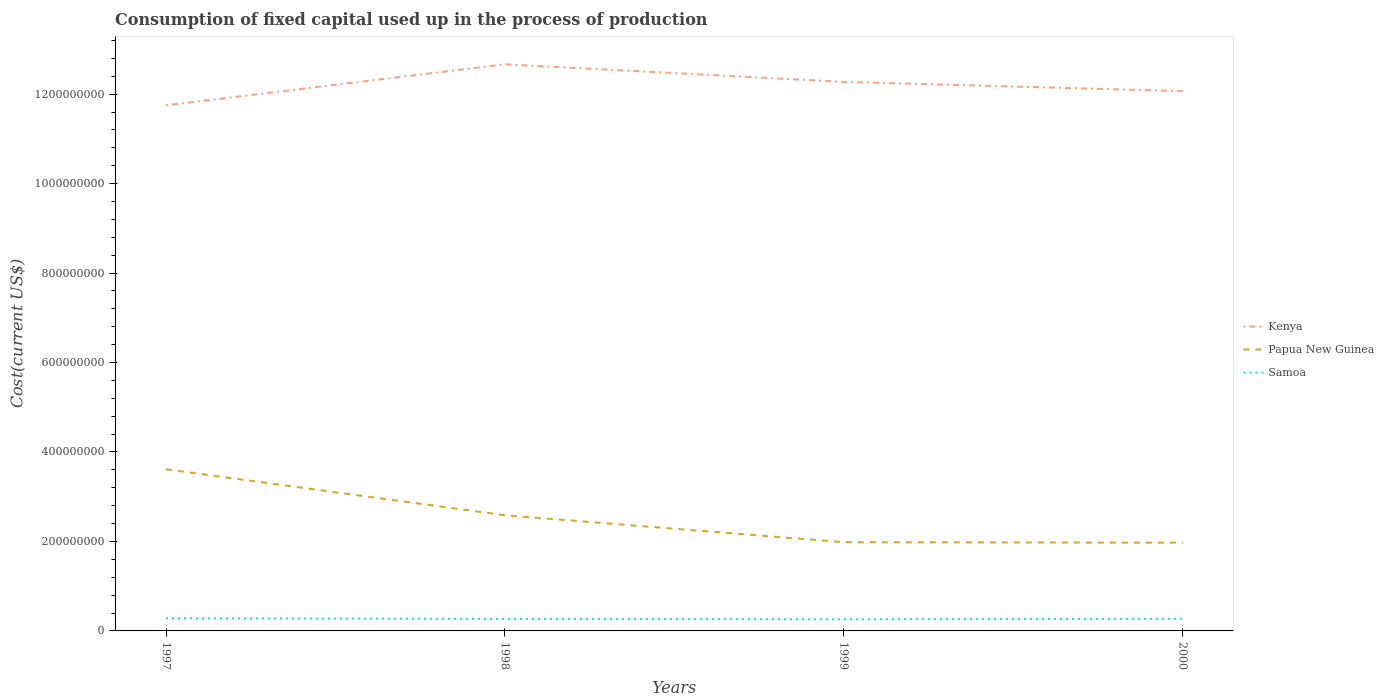How many different coloured lines are there?
Make the answer very short. 3. Is the number of lines equal to the number of legend labels?
Offer a very short reply. Yes. Across all years, what is the maximum amount consumed in the process of production in Papua New Guinea?
Keep it short and to the point. 1.97e+08. What is the total amount consumed in the process of production in Kenya in the graph?
Offer a terse response. -5.23e+07. What is the difference between the highest and the second highest amount consumed in the process of production in Kenya?
Offer a very short reply. 9.15e+07. Is the amount consumed in the process of production in Papua New Guinea strictly greater than the amount consumed in the process of production in Samoa over the years?
Keep it short and to the point. No. How many years are there in the graph?
Ensure brevity in your answer.  4. What is the difference between two consecutive major ticks on the Y-axis?
Make the answer very short. 2.00e+08. Does the graph contain grids?
Provide a succinct answer. No. How many legend labels are there?
Keep it short and to the point. 3. How are the legend labels stacked?
Make the answer very short. Vertical. What is the title of the graph?
Provide a succinct answer. Consumption of fixed capital used up in the process of production. Does "Least developed countries" appear as one of the legend labels in the graph?
Your answer should be compact. No. What is the label or title of the Y-axis?
Provide a succinct answer. Cost(current US$). What is the Cost(current US$) in Kenya in 1997?
Keep it short and to the point. 1.18e+09. What is the Cost(current US$) of Papua New Guinea in 1997?
Make the answer very short. 3.61e+08. What is the Cost(current US$) in Samoa in 1997?
Make the answer very short. 2.85e+07. What is the Cost(current US$) in Kenya in 1998?
Your answer should be very brief. 1.27e+09. What is the Cost(current US$) in Papua New Guinea in 1998?
Offer a very short reply. 2.59e+08. What is the Cost(current US$) of Samoa in 1998?
Ensure brevity in your answer.  2.67e+07. What is the Cost(current US$) of Kenya in 1999?
Your answer should be very brief. 1.23e+09. What is the Cost(current US$) of Papua New Guinea in 1999?
Your response must be concise. 1.98e+08. What is the Cost(current US$) in Samoa in 1999?
Your answer should be very brief. 2.60e+07. What is the Cost(current US$) of Kenya in 2000?
Keep it short and to the point. 1.21e+09. What is the Cost(current US$) of Papua New Guinea in 2000?
Make the answer very short. 1.97e+08. What is the Cost(current US$) in Samoa in 2000?
Give a very brief answer. 2.71e+07. Across all years, what is the maximum Cost(current US$) of Kenya?
Offer a very short reply. 1.27e+09. Across all years, what is the maximum Cost(current US$) of Papua New Guinea?
Your answer should be compact. 3.61e+08. Across all years, what is the maximum Cost(current US$) of Samoa?
Provide a short and direct response. 2.85e+07. Across all years, what is the minimum Cost(current US$) of Kenya?
Provide a short and direct response. 1.18e+09. Across all years, what is the minimum Cost(current US$) of Papua New Guinea?
Your answer should be compact. 1.97e+08. Across all years, what is the minimum Cost(current US$) of Samoa?
Provide a succinct answer. 2.60e+07. What is the total Cost(current US$) in Kenya in the graph?
Keep it short and to the point. 4.88e+09. What is the total Cost(current US$) of Papua New Guinea in the graph?
Provide a succinct answer. 1.02e+09. What is the total Cost(current US$) of Samoa in the graph?
Provide a short and direct response. 1.08e+08. What is the difference between the Cost(current US$) of Kenya in 1997 and that in 1998?
Your response must be concise. -9.15e+07. What is the difference between the Cost(current US$) of Papua New Guinea in 1997 and that in 1998?
Offer a very short reply. 1.03e+08. What is the difference between the Cost(current US$) in Samoa in 1997 and that in 1998?
Offer a very short reply. 1.81e+06. What is the difference between the Cost(current US$) in Kenya in 1997 and that in 1999?
Offer a terse response. -5.23e+07. What is the difference between the Cost(current US$) of Papua New Guinea in 1997 and that in 1999?
Your answer should be very brief. 1.63e+08. What is the difference between the Cost(current US$) of Samoa in 1997 and that in 1999?
Ensure brevity in your answer.  2.57e+06. What is the difference between the Cost(current US$) of Kenya in 1997 and that in 2000?
Ensure brevity in your answer.  -3.15e+07. What is the difference between the Cost(current US$) in Papua New Guinea in 1997 and that in 2000?
Provide a succinct answer. 1.64e+08. What is the difference between the Cost(current US$) in Samoa in 1997 and that in 2000?
Provide a succinct answer. 1.40e+06. What is the difference between the Cost(current US$) in Kenya in 1998 and that in 1999?
Make the answer very short. 3.92e+07. What is the difference between the Cost(current US$) of Papua New Guinea in 1998 and that in 1999?
Give a very brief answer. 6.02e+07. What is the difference between the Cost(current US$) in Samoa in 1998 and that in 1999?
Provide a succinct answer. 7.52e+05. What is the difference between the Cost(current US$) of Kenya in 1998 and that in 2000?
Give a very brief answer. 6.00e+07. What is the difference between the Cost(current US$) of Papua New Guinea in 1998 and that in 2000?
Offer a very short reply. 6.14e+07. What is the difference between the Cost(current US$) in Samoa in 1998 and that in 2000?
Provide a succinct answer. -4.18e+05. What is the difference between the Cost(current US$) of Kenya in 1999 and that in 2000?
Give a very brief answer. 2.08e+07. What is the difference between the Cost(current US$) in Papua New Guinea in 1999 and that in 2000?
Make the answer very short. 1.19e+06. What is the difference between the Cost(current US$) of Samoa in 1999 and that in 2000?
Your answer should be very brief. -1.17e+06. What is the difference between the Cost(current US$) of Kenya in 1997 and the Cost(current US$) of Papua New Guinea in 1998?
Offer a terse response. 9.17e+08. What is the difference between the Cost(current US$) in Kenya in 1997 and the Cost(current US$) in Samoa in 1998?
Offer a terse response. 1.15e+09. What is the difference between the Cost(current US$) of Papua New Guinea in 1997 and the Cost(current US$) of Samoa in 1998?
Your answer should be very brief. 3.35e+08. What is the difference between the Cost(current US$) of Kenya in 1997 and the Cost(current US$) of Papua New Guinea in 1999?
Your answer should be very brief. 9.77e+08. What is the difference between the Cost(current US$) in Kenya in 1997 and the Cost(current US$) in Samoa in 1999?
Offer a very short reply. 1.15e+09. What is the difference between the Cost(current US$) in Papua New Guinea in 1997 and the Cost(current US$) in Samoa in 1999?
Ensure brevity in your answer.  3.35e+08. What is the difference between the Cost(current US$) of Kenya in 1997 and the Cost(current US$) of Papua New Guinea in 2000?
Your answer should be compact. 9.78e+08. What is the difference between the Cost(current US$) in Kenya in 1997 and the Cost(current US$) in Samoa in 2000?
Make the answer very short. 1.15e+09. What is the difference between the Cost(current US$) in Papua New Guinea in 1997 and the Cost(current US$) in Samoa in 2000?
Offer a terse response. 3.34e+08. What is the difference between the Cost(current US$) of Kenya in 1998 and the Cost(current US$) of Papua New Guinea in 1999?
Provide a short and direct response. 1.07e+09. What is the difference between the Cost(current US$) of Kenya in 1998 and the Cost(current US$) of Samoa in 1999?
Your answer should be compact. 1.24e+09. What is the difference between the Cost(current US$) in Papua New Guinea in 1998 and the Cost(current US$) in Samoa in 1999?
Offer a very short reply. 2.33e+08. What is the difference between the Cost(current US$) in Kenya in 1998 and the Cost(current US$) in Papua New Guinea in 2000?
Offer a very short reply. 1.07e+09. What is the difference between the Cost(current US$) of Kenya in 1998 and the Cost(current US$) of Samoa in 2000?
Provide a succinct answer. 1.24e+09. What is the difference between the Cost(current US$) in Papua New Guinea in 1998 and the Cost(current US$) in Samoa in 2000?
Provide a succinct answer. 2.31e+08. What is the difference between the Cost(current US$) of Kenya in 1999 and the Cost(current US$) of Papua New Guinea in 2000?
Offer a terse response. 1.03e+09. What is the difference between the Cost(current US$) in Kenya in 1999 and the Cost(current US$) in Samoa in 2000?
Offer a terse response. 1.20e+09. What is the difference between the Cost(current US$) in Papua New Guinea in 1999 and the Cost(current US$) in Samoa in 2000?
Provide a succinct answer. 1.71e+08. What is the average Cost(current US$) of Kenya per year?
Make the answer very short. 1.22e+09. What is the average Cost(current US$) of Papua New Guinea per year?
Your answer should be compact. 2.54e+08. What is the average Cost(current US$) of Samoa per year?
Your response must be concise. 2.71e+07. In the year 1997, what is the difference between the Cost(current US$) in Kenya and Cost(current US$) in Papua New Guinea?
Offer a terse response. 8.14e+08. In the year 1997, what is the difference between the Cost(current US$) in Kenya and Cost(current US$) in Samoa?
Keep it short and to the point. 1.15e+09. In the year 1997, what is the difference between the Cost(current US$) of Papua New Guinea and Cost(current US$) of Samoa?
Offer a very short reply. 3.33e+08. In the year 1998, what is the difference between the Cost(current US$) of Kenya and Cost(current US$) of Papua New Guinea?
Your answer should be very brief. 1.01e+09. In the year 1998, what is the difference between the Cost(current US$) in Kenya and Cost(current US$) in Samoa?
Ensure brevity in your answer.  1.24e+09. In the year 1998, what is the difference between the Cost(current US$) in Papua New Guinea and Cost(current US$) in Samoa?
Your response must be concise. 2.32e+08. In the year 1999, what is the difference between the Cost(current US$) of Kenya and Cost(current US$) of Papua New Guinea?
Keep it short and to the point. 1.03e+09. In the year 1999, what is the difference between the Cost(current US$) in Kenya and Cost(current US$) in Samoa?
Ensure brevity in your answer.  1.20e+09. In the year 1999, what is the difference between the Cost(current US$) in Papua New Guinea and Cost(current US$) in Samoa?
Provide a succinct answer. 1.72e+08. In the year 2000, what is the difference between the Cost(current US$) in Kenya and Cost(current US$) in Papua New Guinea?
Your response must be concise. 1.01e+09. In the year 2000, what is the difference between the Cost(current US$) of Kenya and Cost(current US$) of Samoa?
Your response must be concise. 1.18e+09. In the year 2000, what is the difference between the Cost(current US$) in Papua New Guinea and Cost(current US$) in Samoa?
Your response must be concise. 1.70e+08. What is the ratio of the Cost(current US$) of Kenya in 1997 to that in 1998?
Make the answer very short. 0.93. What is the ratio of the Cost(current US$) in Papua New Guinea in 1997 to that in 1998?
Offer a very short reply. 1.4. What is the ratio of the Cost(current US$) of Samoa in 1997 to that in 1998?
Provide a short and direct response. 1.07. What is the ratio of the Cost(current US$) in Kenya in 1997 to that in 1999?
Offer a terse response. 0.96. What is the ratio of the Cost(current US$) of Papua New Guinea in 1997 to that in 1999?
Give a very brief answer. 1.82. What is the ratio of the Cost(current US$) in Samoa in 1997 to that in 1999?
Your answer should be compact. 1.1. What is the ratio of the Cost(current US$) in Kenya in 1997 to that in 2000?
Keep it short and to the point. 0.97. What is the ratio of the Cost(current US$) in Papua New Guinea in 1997 to that in 2000?
Provide a short and direct response. 1.83. What is the ratio of the Cost(current US$) of Samoa in 1997 to that in 2000?
Your answer should be compact. 1.05. What is the ratio of the Cost(current US$) in Kenya in 1998 to that in 1999?
Give a very brief answer. 1.03. What is the ratio of the Cost(current US$) in Papua New Guinea in 1998 to that in 1999?
Make the answer very short. 1.3. What is the ratio of the Cost(current US$) in Kenya in 1998 to that in 2000?
Your response must be concise. 1.05. What is the ratio of the Cost(current US$) of Papua New Guinea in 1998 to that in 2000?
Provide a short and direct response. 1.31. What is the ratio of the Cost(current US$) of Samoa in 1998 to that in 2000?
Your answer should be very brief. 0.98. What is the ratio of the Cost(current US$) in Kenya in 1999 to that in 2000?
Ensure brevity in your answer.  1.02. What is the ratio of the Cost(current US$) of Papua New Guinea in 1999 to that in 2000?
Provide a succinct answer. 1.01. What is the ratio of the Cost(current US$) of Samoa in 1999 to that in 2000?
Make the answer very short. 0.96. What is the difference between the highest and the second highest Cost(current US$) of Kenya?
Provide a short and direct response. 3.92e+07. What is the difference between the highest and the second highest Cost(current US$) in Papua New Guinea?
Make the answer very short. 1.03e+08. What is the difference between the highest and the second highest Cost(current US$) in Samoa?
Give a very brief answer. 1.40e+06. What is the difference between the highest and the lowest Cost(current US$) of Kenya?
Keep it short and to the point. 9.15e+07. What is the difference between the highest and the lowest Cost(current US$) in Papua New Guinea?
Provide a short and direct response. 1.64e+08. What is the difference between the highest and the lowest Cost(current US$) in Samoa?
Your answer should be compact. 2.57e+06. 